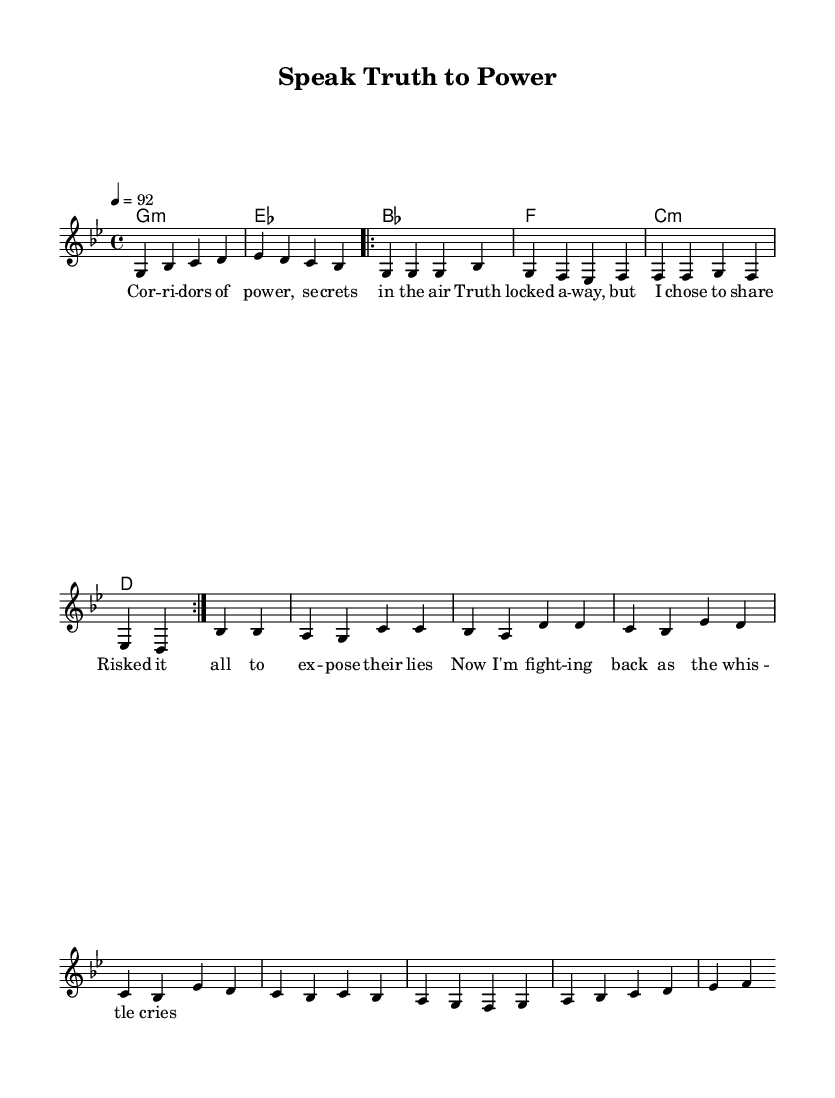What is the key signature of this music? The key signature displays one flat, indicating that the piece is in G minor, which has two flats (B flat, E flat).
Answer: G minor What is the time signature of this music? The time signature is noted as 4/4, meaning there are four beats per measure and the quarter note receives one beat.
Answer: 4/4 What is the tempo marking for this piece? The tempo marking indicates a speed of 92 beats per minute, as shown by "4 = 92."
Answer: 92 How many times is the verse repeated? The notation states "repeat volta 2," which means the verse is played twice.
Answer: 2 What type of chords are primarily used in this piece? The chords indicated in the chord mode include minor and dominant seventh chords, reflecting the characteristics of hip-hop music.
Answer: Minor, dominant What is the main theme of the lyrics? The lyrics center on themes of corporate secrecy, whistleblowing, and fighting against oppression, characteristic of socially conscious rap.
Answer: Corporate secrecy, whistleblowing How many measures are present in the chorus? The chorus is structured across four measures, which can be counted from the notated sections.
Answer: 4 